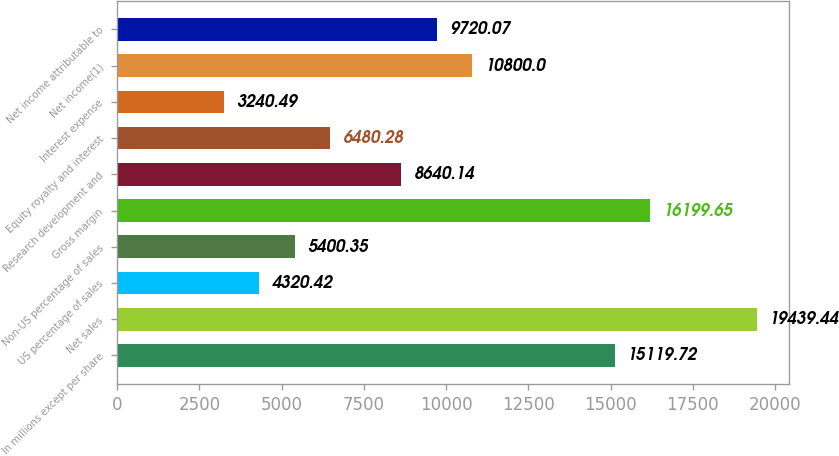<chart> <loc_0><loc_0><loc_500><loc_500><bar_chart><fcel>In millions except per share<fcel>Net sales<fcel>US percentage of sales<fcel>Non-US percentage of sales<fcel>Gross margin<fcel>Research development and<fcel>Equity royalty and interest<fcel>Interest expense<fcel>Net income(1)<fcel>Net income attributable to<nl><fcel>15119.7<fcel>19439.4<fcel>4320.42<fcel>5400.35<fcel>16199.6<fcel>8640.14<fcel>6480.28<fcel>3240.49<fcel>10800<fcel>9720.07<nl></chart> 